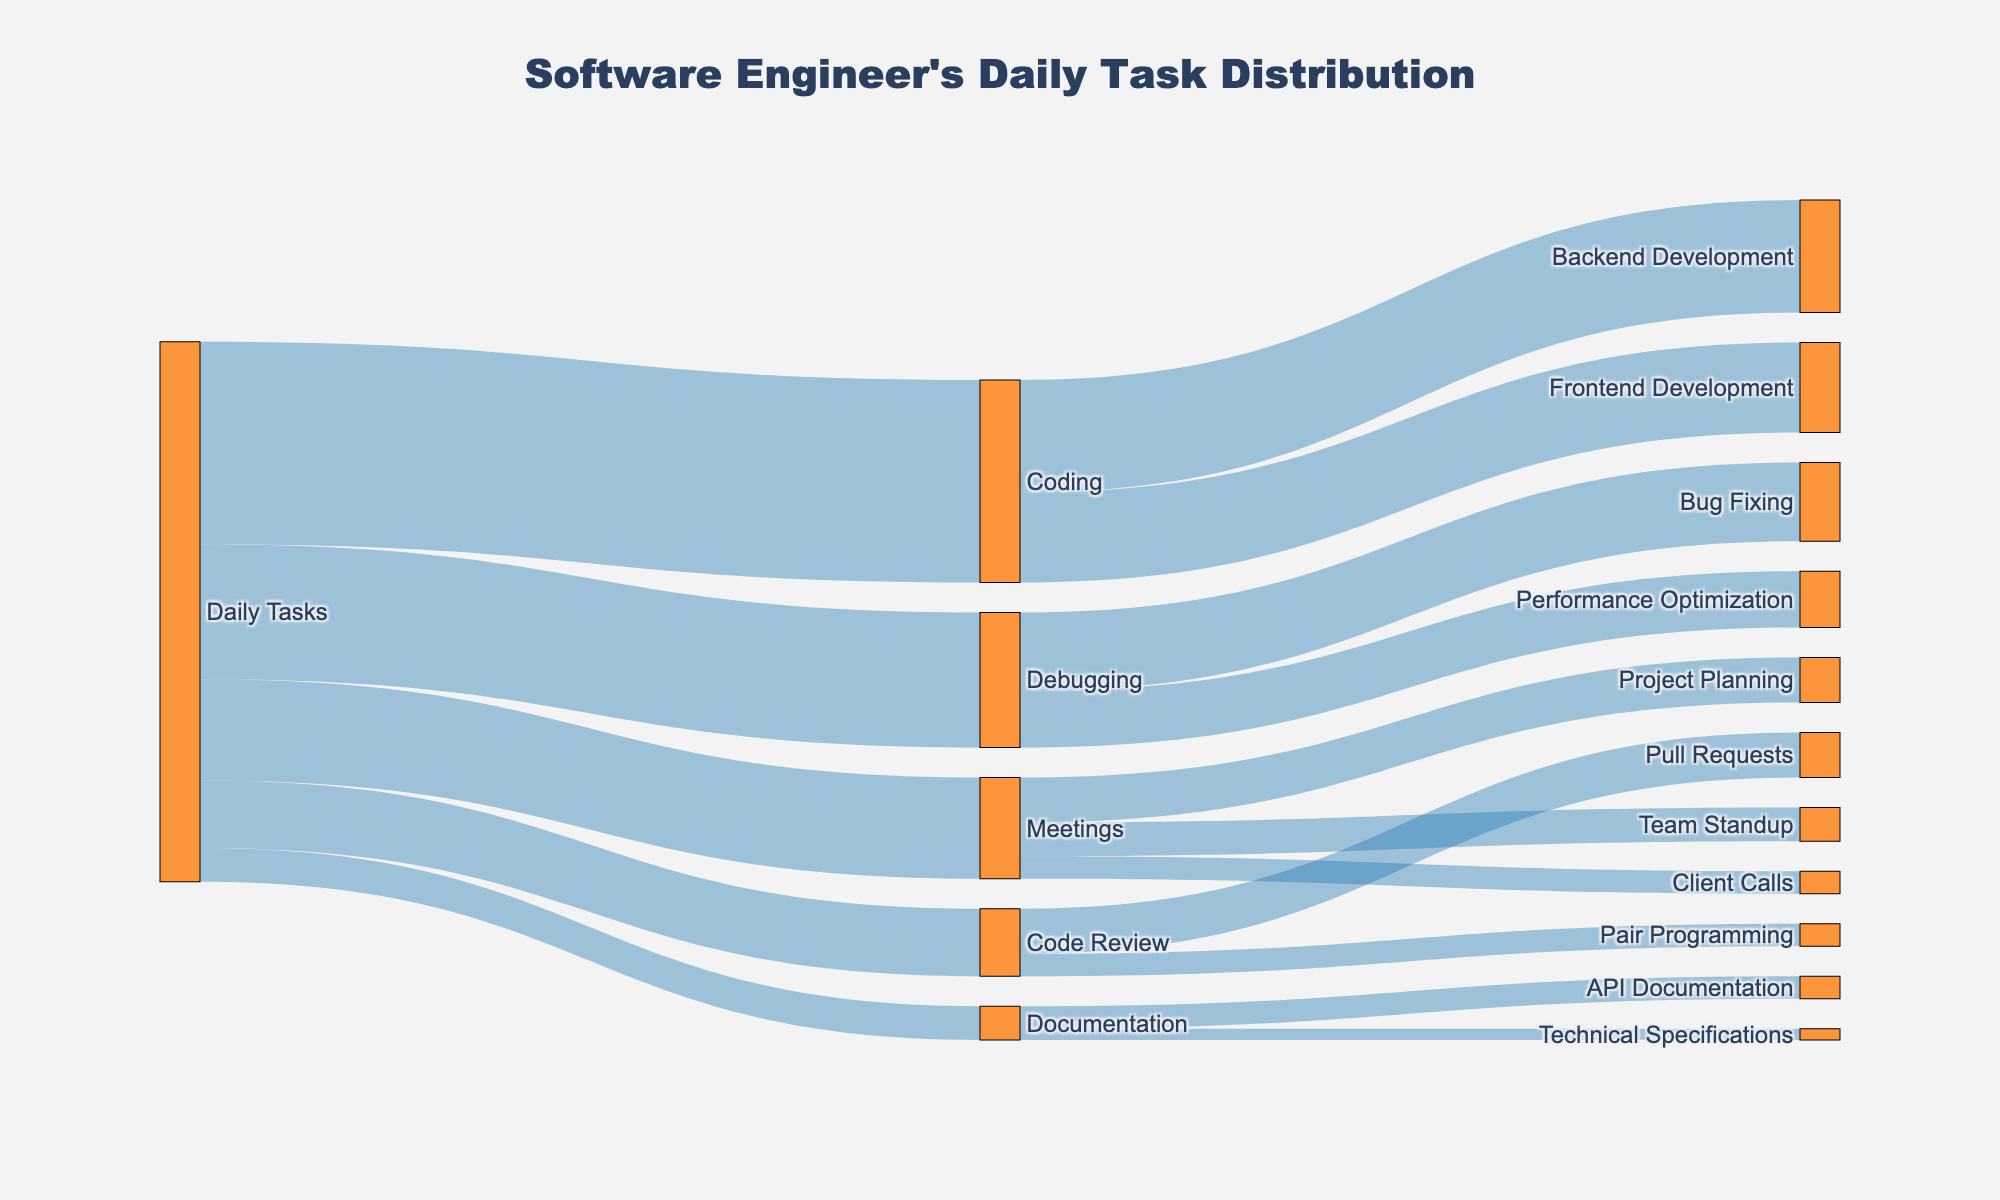What is the title of the Sankey diagram? The title of a diagram is generally found at the top of the figure. From the description and code, it's indicated that the title is "Software Engineer's Daily Task Distribution".
Answer: Software Engineer's Daily Task Distribution What color are the nodes in the diagram? Based on the code, the nodes in the diagram are colored orange with some transparency. This color is defined to make the nodes visually distinct.
Answer: Orange How much time is spent on meetings? To answer this, identify the link within the diagram that connects "Daily Tasks" to "Meetings". The corresponding value beside this link represents the time. From the data, it shows 90 minutes spent on meetings.
Answer: 90 minutes What percentage of the workday is spent on coding? First sum up the total time for all daily tasks (180 + 90 + 120 + 60 + 30 = 480). Then, calculate the percentage spent on coding (180/480 * 100).
Answer: 37.5% Which coding task takes more time: frontend development or backend development? Look at the connections from "Coding" to its subsequent tasks. Compare the values associated with "Frontend Development" and "Backend Development". From the data, backend development is 100 minutes and frontend development is 80 minutes, so backend development takes more time.
Answer: Backend Development Which type of meeting takes the least time? Out of the different types of meetings (Team Standup, Project Planning, and Client Calls), compare their respective times. From the data, Client Calls take the least time at 20 minutes.
Answer: Client Calls What is the combined time spent on code review activities? Add the times spent on the two activities under code review: "Pull Requests" and "Pair Programming". Based on the data, it is 40 + 20 = 60 minutes.
Answer: 60 minutes Compare the time spent on API documentation and Technical Specifications. Which one is more? Look at the time values for "API Documentation" and "Technical Specifications". From the data, API Documentation takes 20 minutes, while Technical Specifications take 10 minutes, so API Documentation takes more time.
Answer: API Documentation If the total duration of debugging tasks increased by 30 minutes, what would be the new total duration for debugging? The original time for debugging is 120 minutes. If debugging tasks increased by 30 minutes, simply add this to 120.
Answer: 150 minutes How does time spent on debugging compare to time spent on meetings? Compare the values directly: Debugging is 120 minutes, and Meetings are 90 minutes. Debugging takes more time.
Answer: Debugging takes more time 